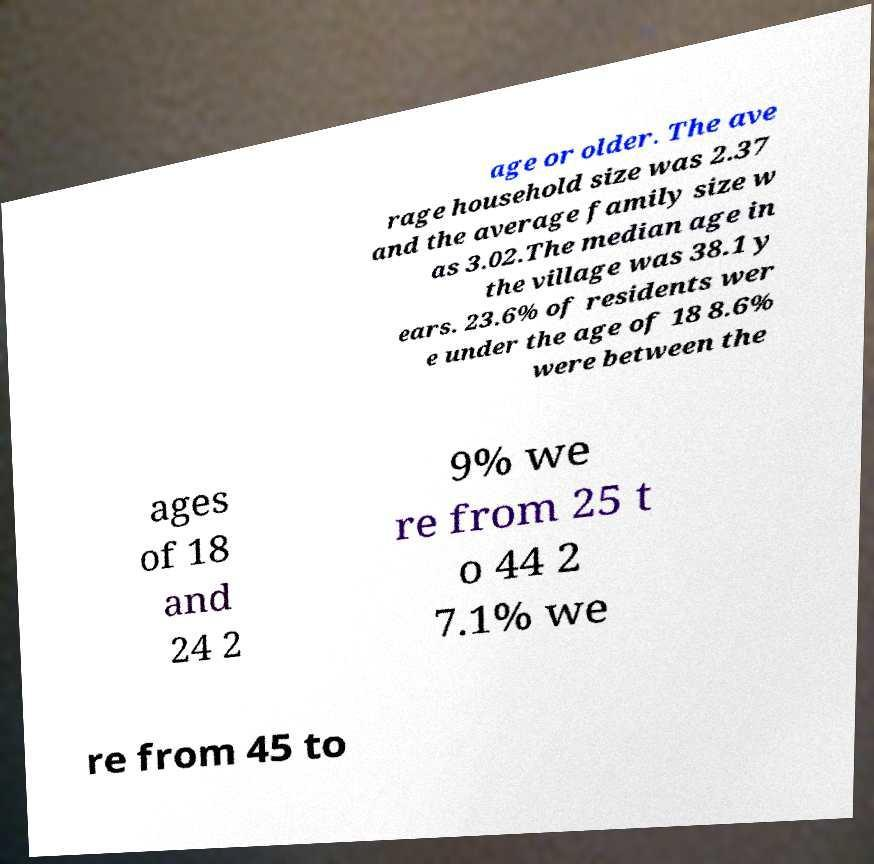For documentation purposes, I need the text within this image transcribed. Could you provide that? age or older. The ave rage household size was 2.37 and the average family size w as 3.02.The median age in the village was 38.1 y ears. 23.6% of residents wer e under the age of 18 8.6% were between the ages of 18 and 24 2 9% we re from 25 t o 44 2 7.1% we re from 45 to 